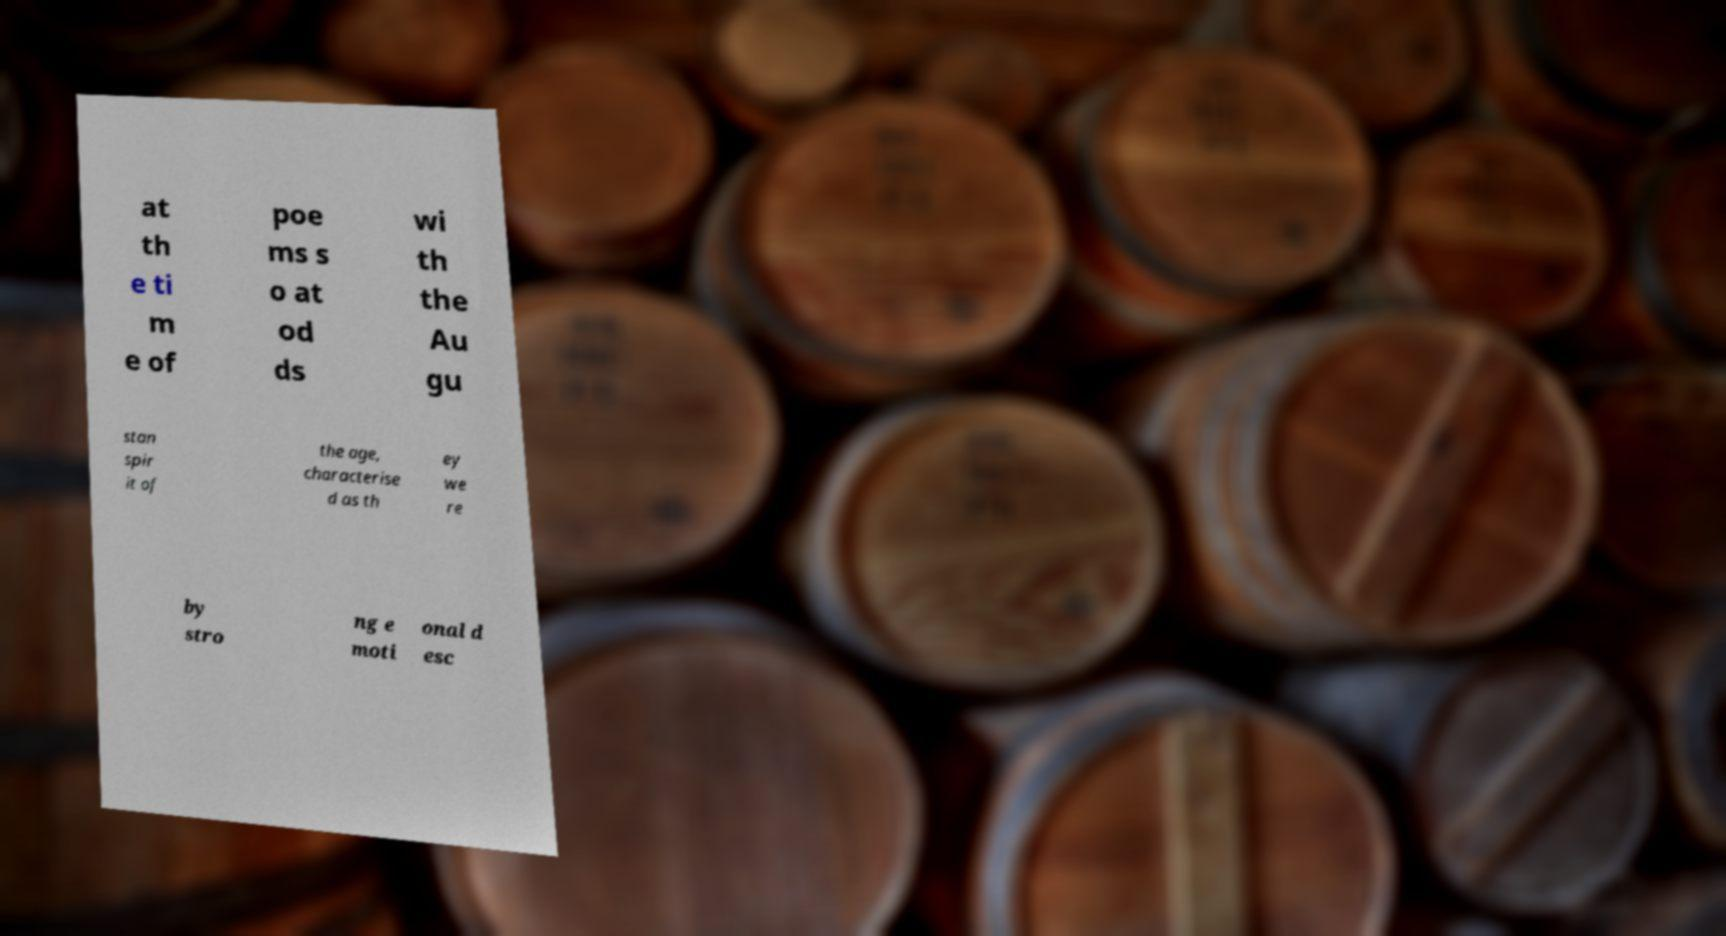Could you assist in decoding the text presented in this image and type it out clearly? at th e ti m e of poe ms s o at od ds wi th the Au gu stan spir it of the age, characterise d as th ey we re by stro ng e moti onal d esc 